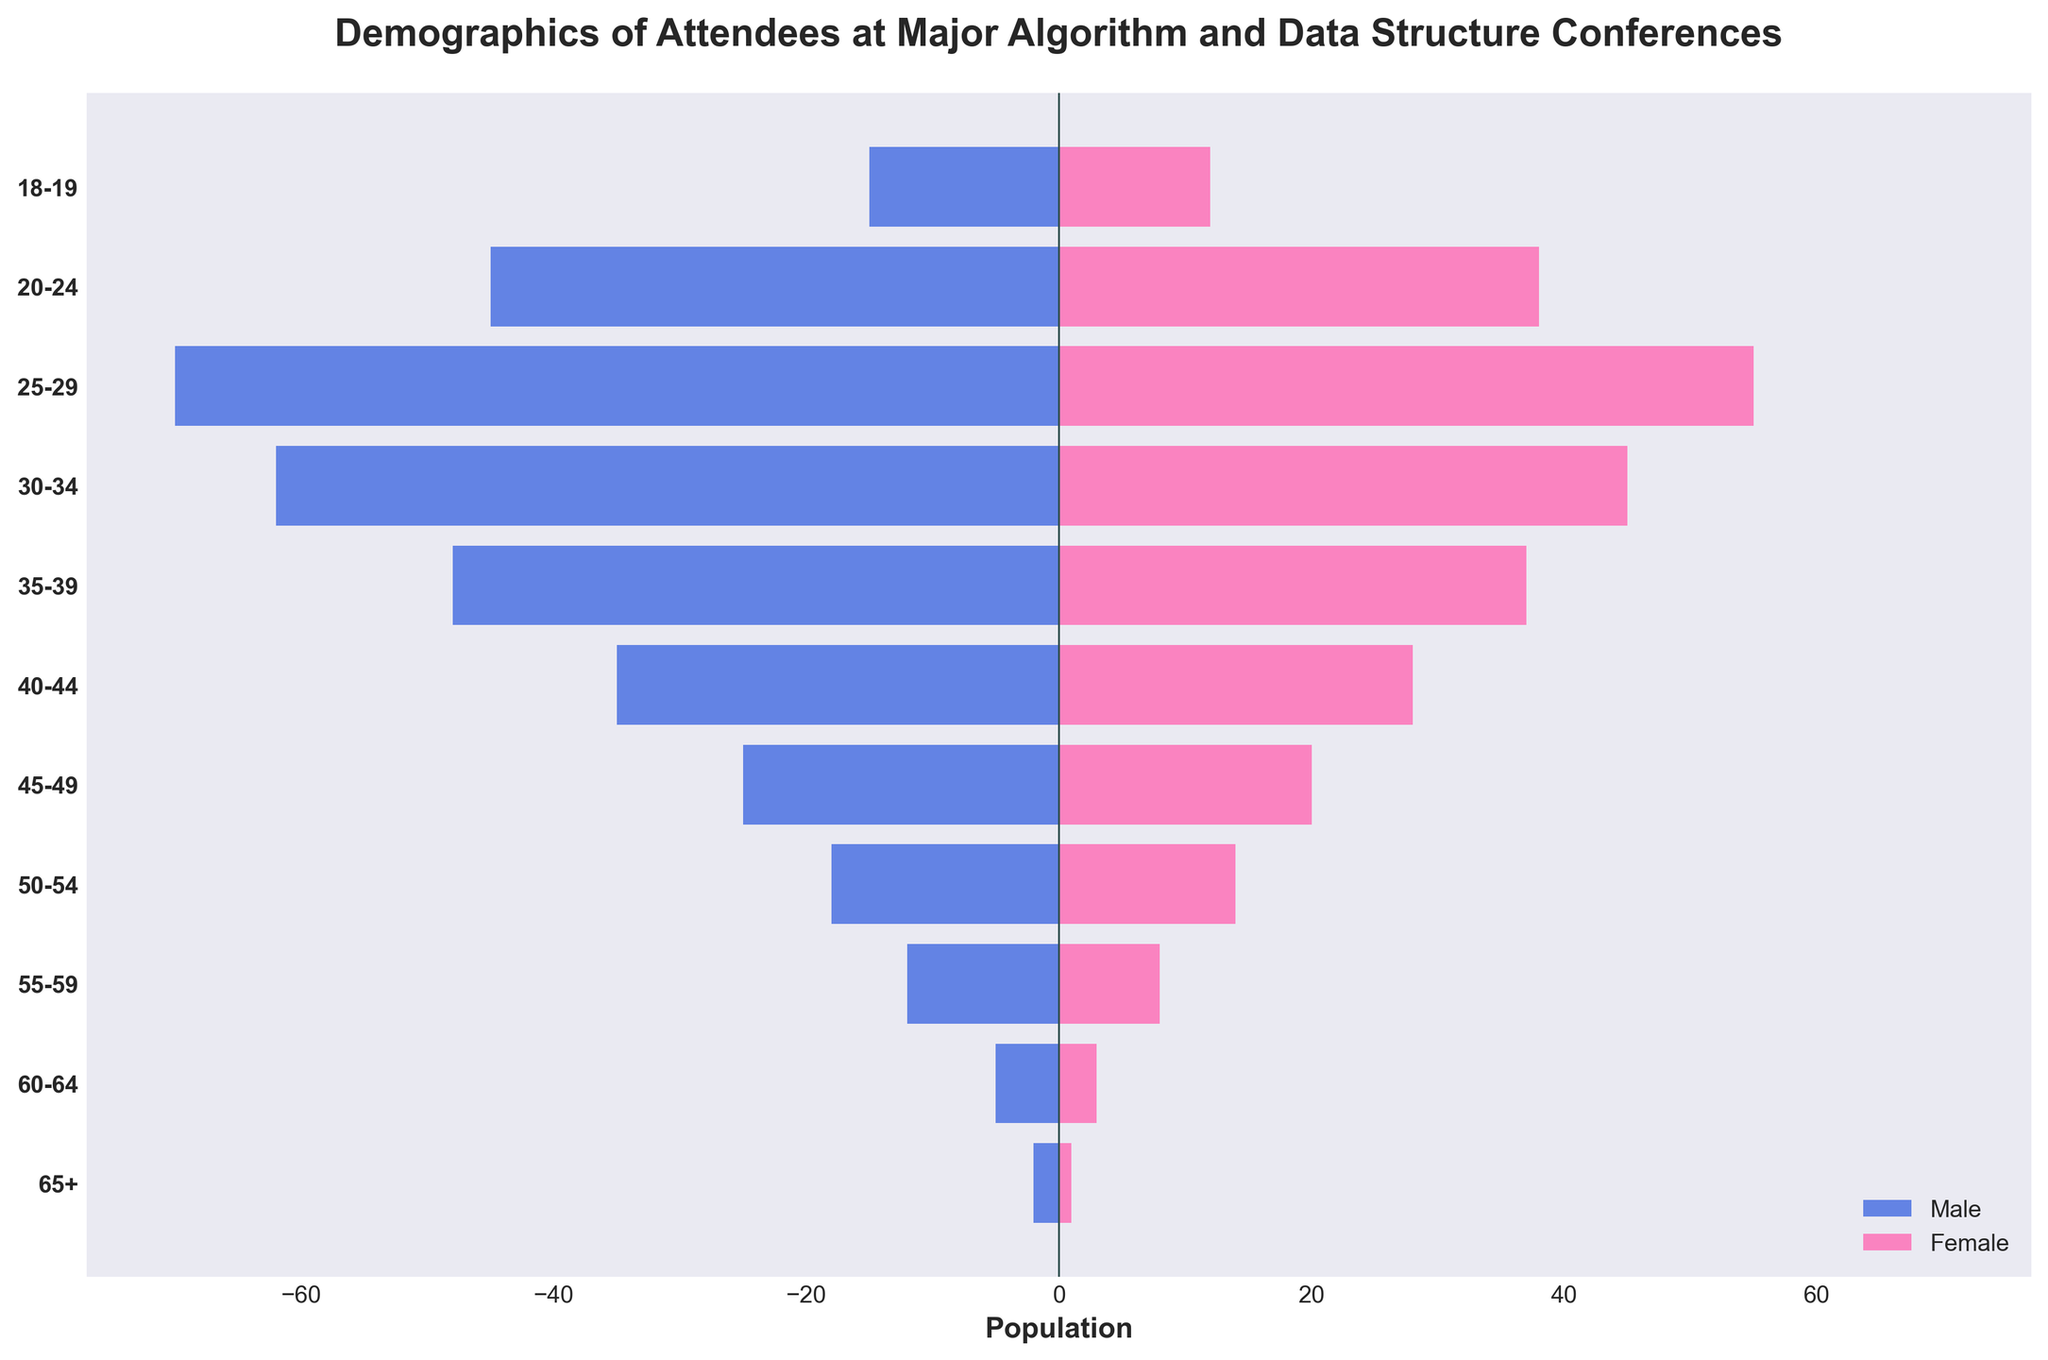How many age groups are represented in the figure? The y-axis lists the age groups. Count the number of unique age groups presented in the list.
Answer: 11 Which age group has the highest number of female attendees? Check the female section of the bars and identify the one with the greatest length.
Answer: 25-29 What is the total number of male attendees in the 35-39 and 30-34 age groups? Identify the male values for each age group from the figure and sum them: 35-39 has 48, 30-34 has 62. The total is 48 + 62.
Answer: 110 Is the number of female attendees in the 45-49 age group greater than the number of male attendees in the 55-59 age group? Compare the female value for 45-49 with the male value for 55-59. 45-49 has 20 females, and 55-59 has 12 males.
Answer: Yes Which age group has more male attendees: 20-24 or 60-64? Compare the male values for each group, 20-24 has 45 males, and 60-64 has 5 males.
Answer: 20-24 What is the sum of female attendees in the 18-19, 25-29, and 55-59 age groups? Add the female values for each group: 18-19 has 12, 25-29 has 55, and 55-59 has 8. The sum is 12 + 55 + 8.
Answer: 75 Which age group has the lowest number of attendees overall? Check the combined length of male and female values for each group and find the smallest combination. 65+ has a total of 3 attendees.
Answer: 65+ How balanced is the gender ratio among attendees aged 30-34? Compare the male and female values for the 30-34 age group, which has 62 males and 45 females. Calculate the ratio (62/45) to find the balance.
Answer: Male: 62, Female: 45 In which age group is the difference between the number of male and female attendees the largest? Subtract the female values from the male values for all age groups and identify the maximum difference. For 30-34, the difference is 62 - 45 = 17, which is the largest.
Answer: 30-34 